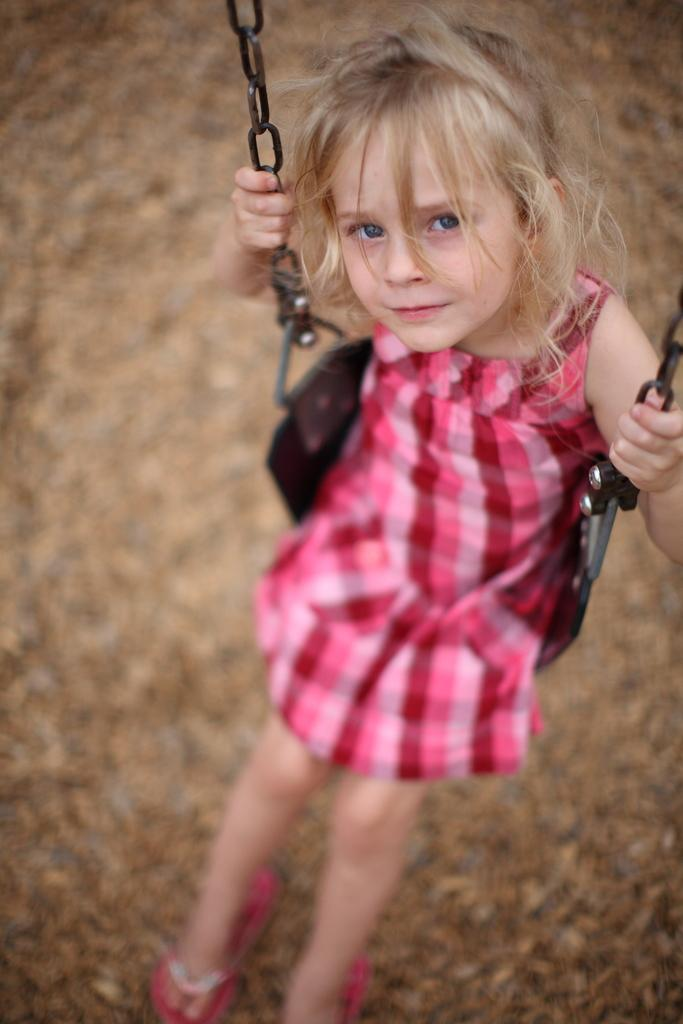What is the person in the image doing? The person is sitting on an object in the image. What is the person holding in the image? The person is holding an object in the image. What can be seen behind the person in the image? There is a background visible in the image. Are there any birds visible in the park during the holiday in the image? There is no information about a park, holiday, or birds in the image, so we cannot answer that question. 